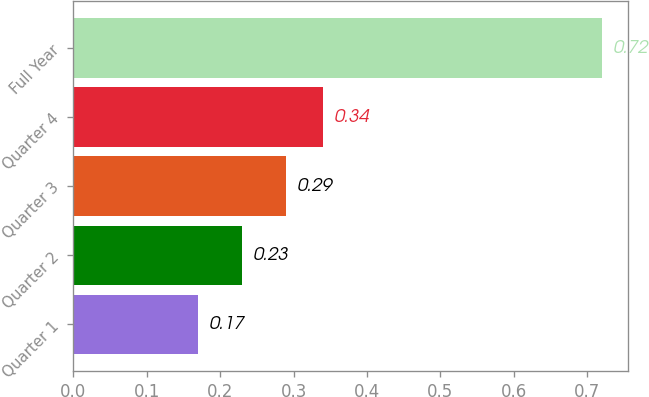<chart> <loc_0><loc_0><loc_500><loc_500><bar_chart><fcel>Quarter 1<fcel>Quarter 2<fcel>Quarter 3<fcel>Quarter 4<fcel>Full Year<nl><fcel>0.17<fcel>0.23<fcel>0.29<fcel>0.34<fcel>0.72<nl></chart> 